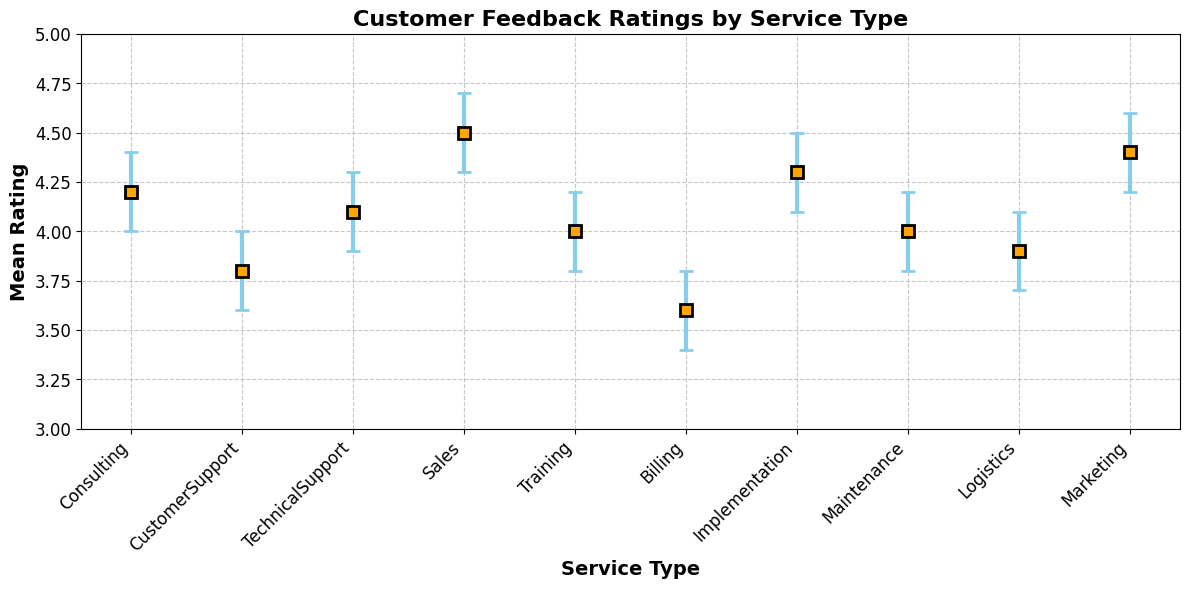What's the title of the figure? The title of the figure is located at the top and is set in bold. By reading the title, one can determine the main topic being visualized.
Answer: Customer Feedback Ratings by Service Type Which service type has the highest mean rating? By visually inspecting the vertical positions of the markers representing each service type, the one at the highest point corresponds to the highest mean rating.
Answer: Sales What is the mean rating for the 'Technical Support' service? Locate the marker corresponding to 'Technical Support' on the horizontal axis and read the associated value on the vertical axis.
Answer: 4.1 Which service type has the smallest confidence interval? By examining the error bars of each service type, the one with the shortest error bars (i.e., the smallest range) is identified.
Answer: Sales How many service types have a mean rating above 4.0? Count all the markers that are positioned above the 4.0 mark on the vertical axis.
Answer: 6 What is the range of the mean rating for 'Customer Support'? Find the 'LowerCI' and 'UpperCI' values for 'Customer Support' by observing the error bars, and calculate the range (UpperCI - LowerCI).
Answer: 0.4 Compare the mean ratings of 'Consulting' and 'Marketing'. Which one is higher? Identify the vertical positions of the markers for 'Consulting' and 'Marketing' and compare their mean ratings.
Answer: Marketing What is the average mean rating across all service types? Add up all the mean ratings and divide by the number of service types: (4.2 + 3.8 + 4.1 + 4.5 + 4.0 + 3.6 + 4.3 + 4.0 + 3.9 + 4.4) / 10.
Answer: 4.08 Is there any service type with a mean rating of 3.6 or less? Identify the markers positioned at 3.6 or lower on the vertical axis.
Answer: Yes (Billing) 